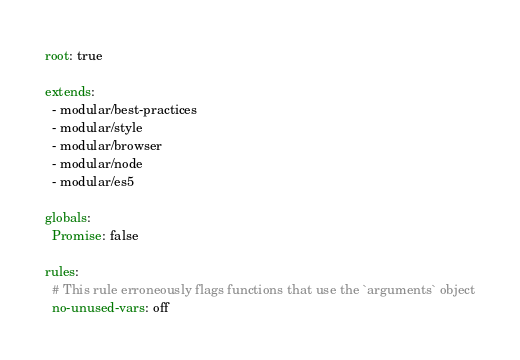<code> <loc_0><loc_0><loc_500><loc_500><_YAML_>
root: true

extends:
  - modular/best-practices
  - modular/style
  - modular/browser
  - modular/node
  - modular/es5

globals:
  Promise: false

rules:
  # This rule erroneously flags functions that use the `arguments` object
  no-unused-vars: off
</code> 